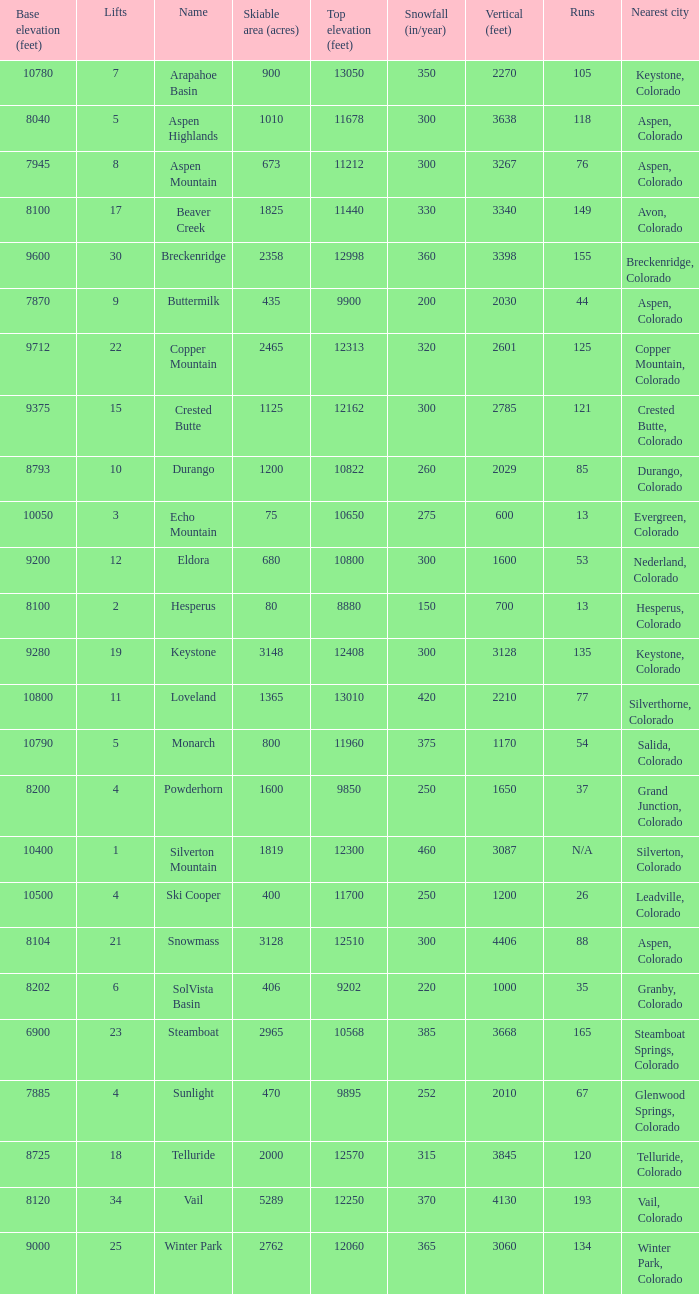Could you parse the entire table as a dict? {'header': ['Base elevation (feet)', 'Lifts', 'Name', 'Skiable area (acres)', 'Top elevation (feet)', 'Snowfall (in/year)', 'Vertical (feet)', 'Runs', 'Nearest city'], 'rows': [['10780', '7', 'Arapahoe Basin', '900', '13050', '350', '2270', '105', 'Keystone, Colorado'], ['8040', '5', 'Aspen Highlands', '1010', '11678', '300', '3638', '118', 'Aspen, Colorado'], ['7945', '8', 'Aspen Mountain', '673', '11212', '300', '3267', '76', 'Aspen, Colorado'], ['8100', '17', 'Beaver Creek', '1825', '11440', '330', '3340', '149', 'Avon, Colorado'], ['9600', '30', 'Breckenridge', '2358', '12998', '360', '3398', '155', 'Breckenridge, Colorado'], ['7870', '9', 'Buttermilk', '435', '9900', '200', '2030', '44', 'Aspen, Colorado'], ['9712', '22', 'Copper Mountain', '2465', '12313', '320', '2601', '125', 'Copper Mountain, Colorado'], ['9375', '15', 'Crested Butte', '1125', '12162', '300', '2785', '121', 'Crested Butte, Colorado'], ['8793', '10', 'Durango', '1200', '10822', '260', '2029', '85', 'Durango, Colorado'], ['10050', '3', 'Echo Mountain', '75', '10650', '275', '600', '13', 'Evergreen, Colorado'], ['9200', '12', 'Eldora', '680', '10800', '300', '1600', '53', 'Nederland, Colorado'], ['8100', '2', 'Hesperus', '80', '8880', '150', '700', '13', 'Hesperus, Colorado'], ['9280', '19', 'Keystone', '3148', '12408', '300', '3128', '135', 'Keystone, Colorado'], ['10800', '11', 'Loveland', '1365', '13010', '420', '2210', '77', 'Silverthorne, Colorado'], ['10790', '5', 'Monarch', '800', '11960', '375', '1170', '54', 'Salida, Colorado'], ['8200', '4', 'Powderhorn', '1600', '9850', '250', '1650', '37', 'Grand Junction, Colorado'], ['10400', '1', 'Silverton Mountain', '1819', '12300', '460', '3087', 'N/A', 'Silverton, Colorado'], ['10500', '4', 'Ski Cooper', '400', '11700', '250', '1200', '26', 'Leadville, Colorado'], ['8104', '21', 'Snowmass', '3128', '12510', '300', '4406', '88', 'Aspen, Colorado'], ['8202', '6', 'SolVista Basin', '406', '9202', '220', '1000', '35', 'Granby, Colorado'], ['6900', '23', 'Steamboat', '2965', '10568', '385', '3668', '165', 'Steamboat Springs, Colorado'], ['7885', '4', 'Sunlight', '470', '9895', '252', '2010', '67', 'Glenwood Springs, Colorado'], ['8725', '18', 'Telluride', '2000', '12570', '315', '3845', '120', 'Telluride, Colorado'], ['8120', '34', 'Vail', '5289', '12250', '370', '4130', '193', 'Vail, Colorado'], ['9000', '25', 'Winter Park', '2762', '12060', '365', '3060', '134', 'Winter Park, Colorado']]} If there are 30 lifts, what is the name of the ski resort? Breckenridge. 